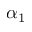Convert formula to latex. <formula><loc_0><loc_0><loc_500><loc_500>\alpha _ { 1 }</formula> 